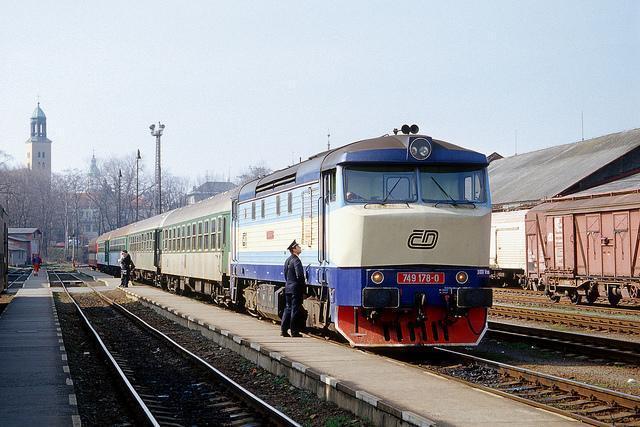How many trains are in the photo?
Give a very brief answer. 2. How many zebras are there?
Give a very brief answer. 0. 